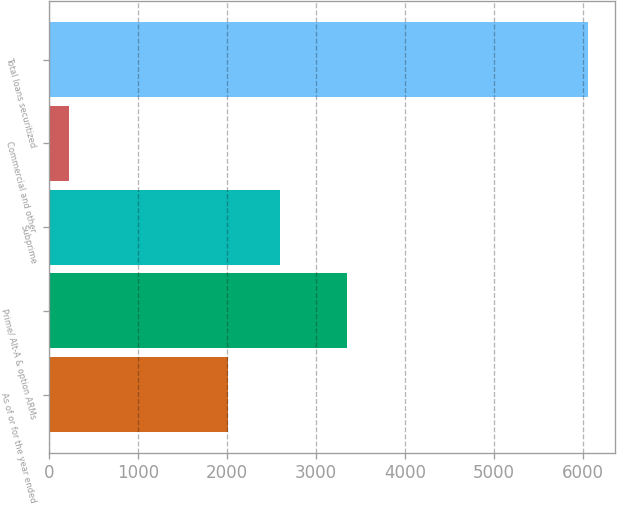Convert chart to OTSL. <chart><loc_0><loc_0><loc_500><loc_500><bar_chart><fcel>As of or for the year ended<fcel>Prime/ Alt-A & option ARMs<fcel>Subprime<fcel>Commercial and other<fcel>Total loans securitized<nl><fcel>2018<fcel>3354<fcel>2601.2<fcel>225<fcel>6057<nl></chart> 